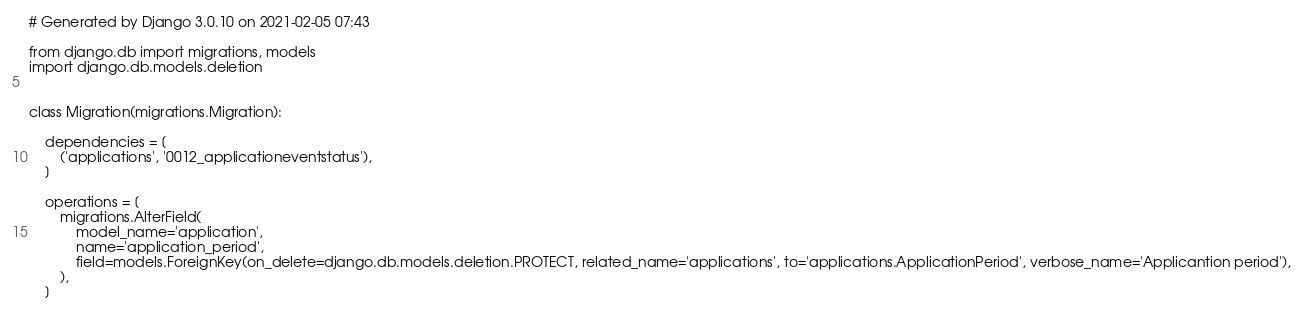Convert code to text. <code><loc_0><loc_0><loc_500><loc_500><_Python_># Generated by Django 3.0.10 on 2021-02-05 07:43

from django.db import migrations, models
import django.db.models.deletion


class Migration(migrations.Migration):

    dependencies = [
        ('applications', '0012_applicationeventstatus'),
    ]

    operations = [
        migrations.AlterField(
            model_name='application',
            name='application_period',
            field=models.ForeignKey(on_delete=django.db.models.deletion.PROTECT, related_name='applications', to='applications.ApplicationPeriod', verbose_name='Applicantion period'),
        ),
    ]
</code> 